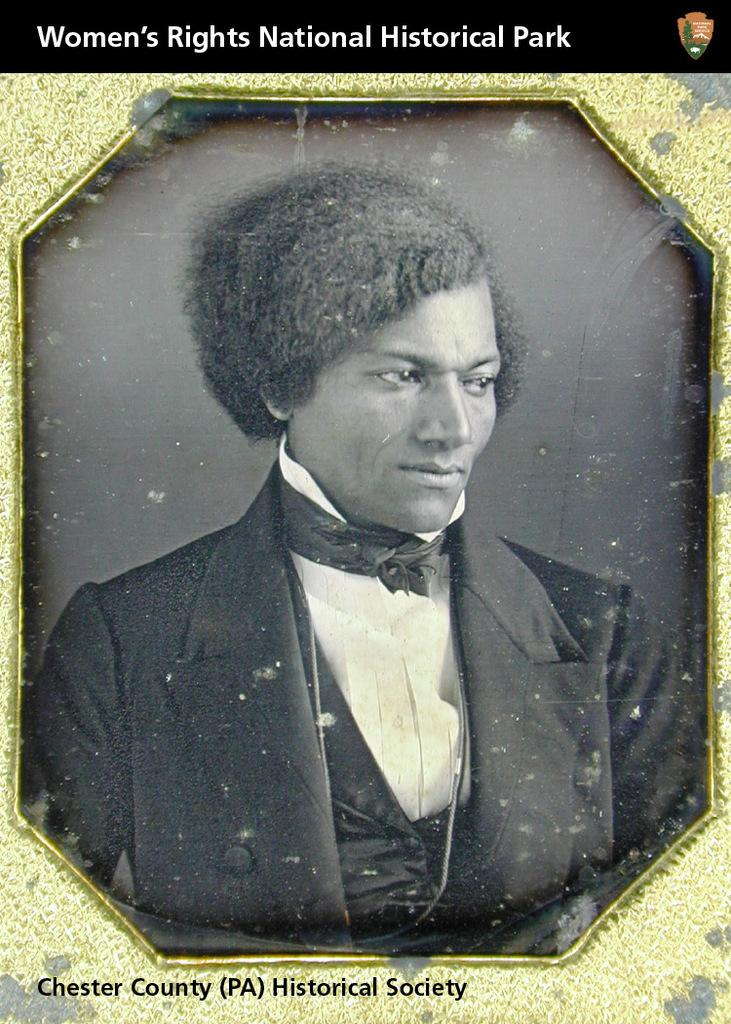Provide a one-sentence caption for the provided image. A picure bearing the words Women's RIghts National Historical Park portrays a very old image of well groomed black man. 